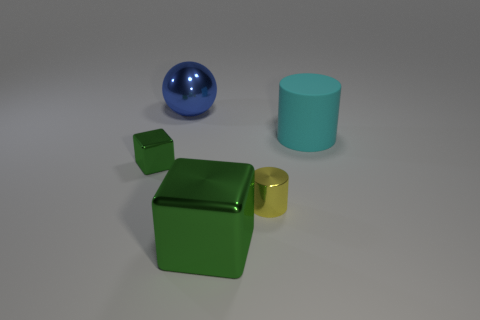Subtract all purple balls. Subtract all blue cubes. How many balls are left? 1 Add 5 big green metal cubes. How many objects exist? 10 Subtract all blocks. How many objects are left? 3 Add 2 tiny green metallic objects. How many tiny green metallic objects exist? 3 Subtract 1 blue spheres. How many objects are left? 4 Subtract all yellow shiny spheres. Subtract all cyan rubber objects. How many objects are left? 4 Add 2 large cyan rubber things. How many large cyan rubber things are left? 3 